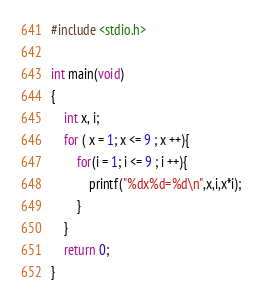<code> <loc_0><loc_0><loc_500><loc_500><_C_>#include <stdio.h>

int main(void)
{
	int x, i;
	for ( x = 1; x <= 9 ; x ++){
		for(i = 1; i <= 9 ; i ++){
			printf("%dx%d=%d\n",x,i,x*i);
		}
	}
	return 0;
}</code> 